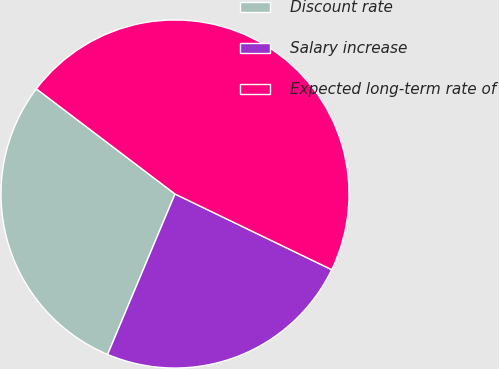Convert chart. <chart><loc_0><loc_0><loc_500><loc_500><pie_chart><fcel>Discount rate<fcel>Salary increase<fcel>Expected long-term rate of<nl><fcel>29.0%<fcel>24.17%<fcel>46.83%<nl></chart> 